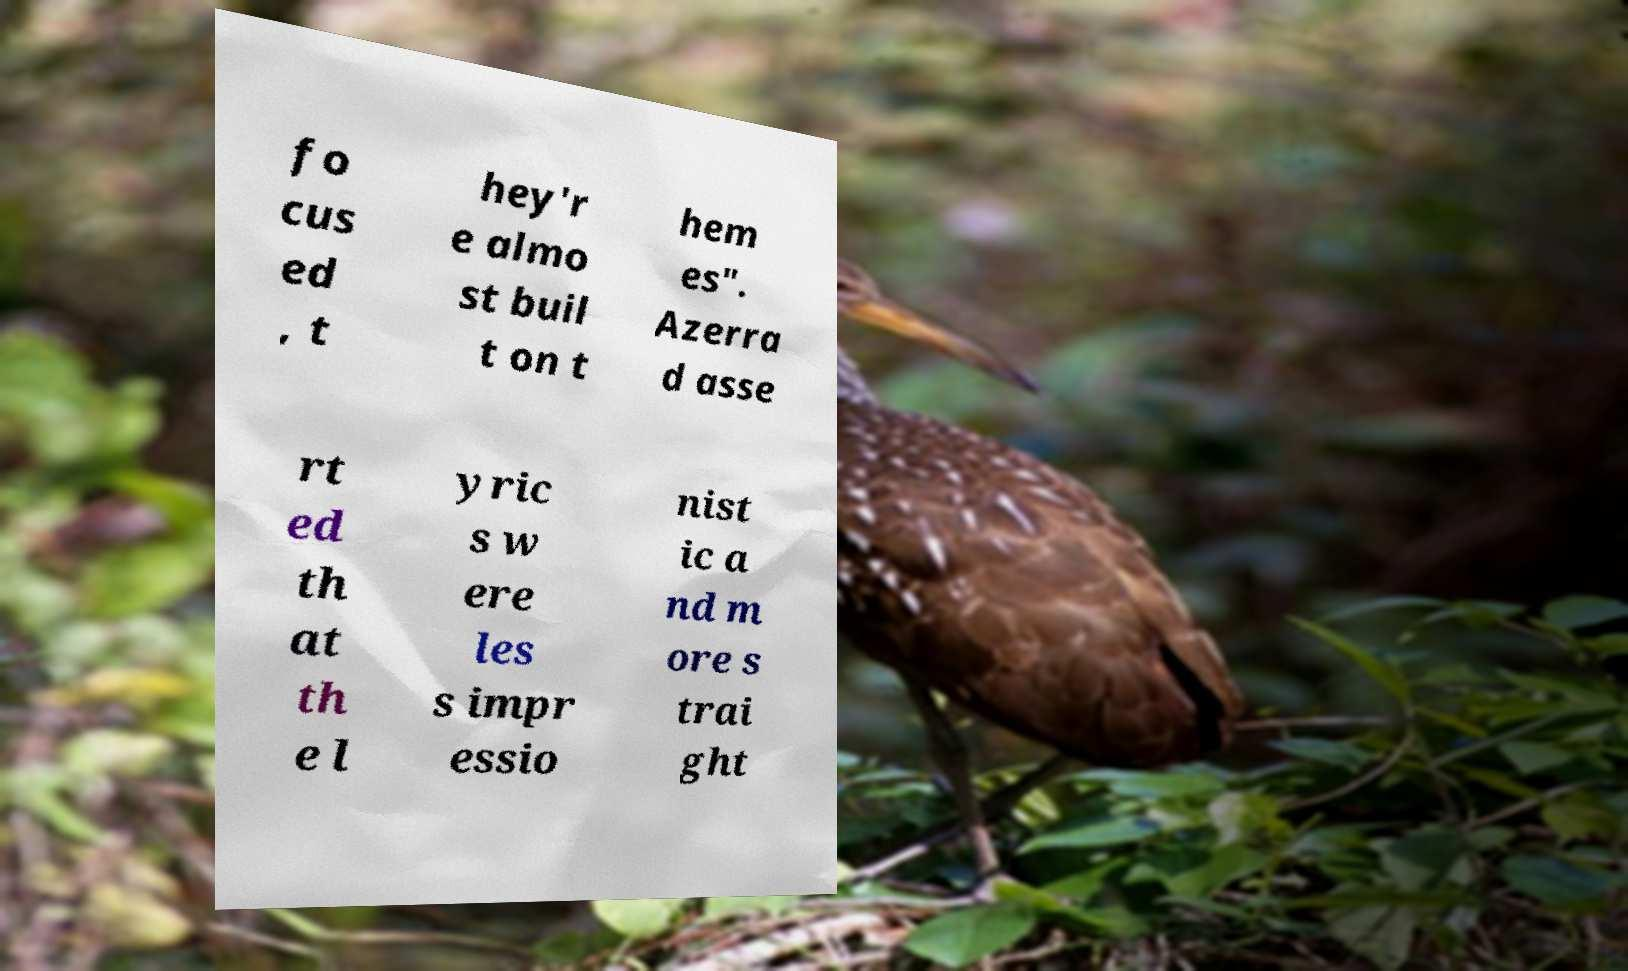I need the written content from this picture converted into text. Can you do that? fo cus ed , t hey'r e almo st buil t on t hem es". Azerra d asse rt ed th at th e l yric s w ere les s impr essio nist ic a nd m ore s trai ght 